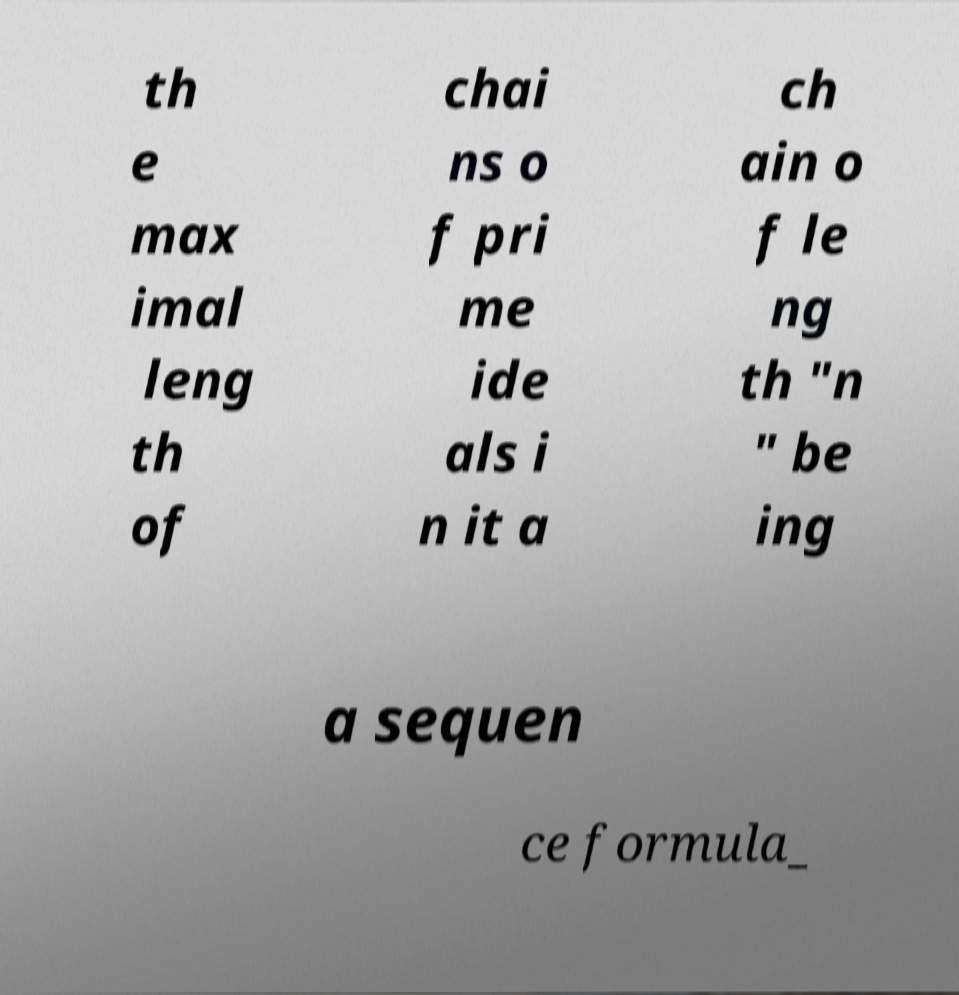What messages or text are displayed in this image? I need them in a readable, typed format. th e max imal leng th of chai ns o f pri me ide als i n it a ch ain o f le ng th "n " be ing a sequen ce formula_ 